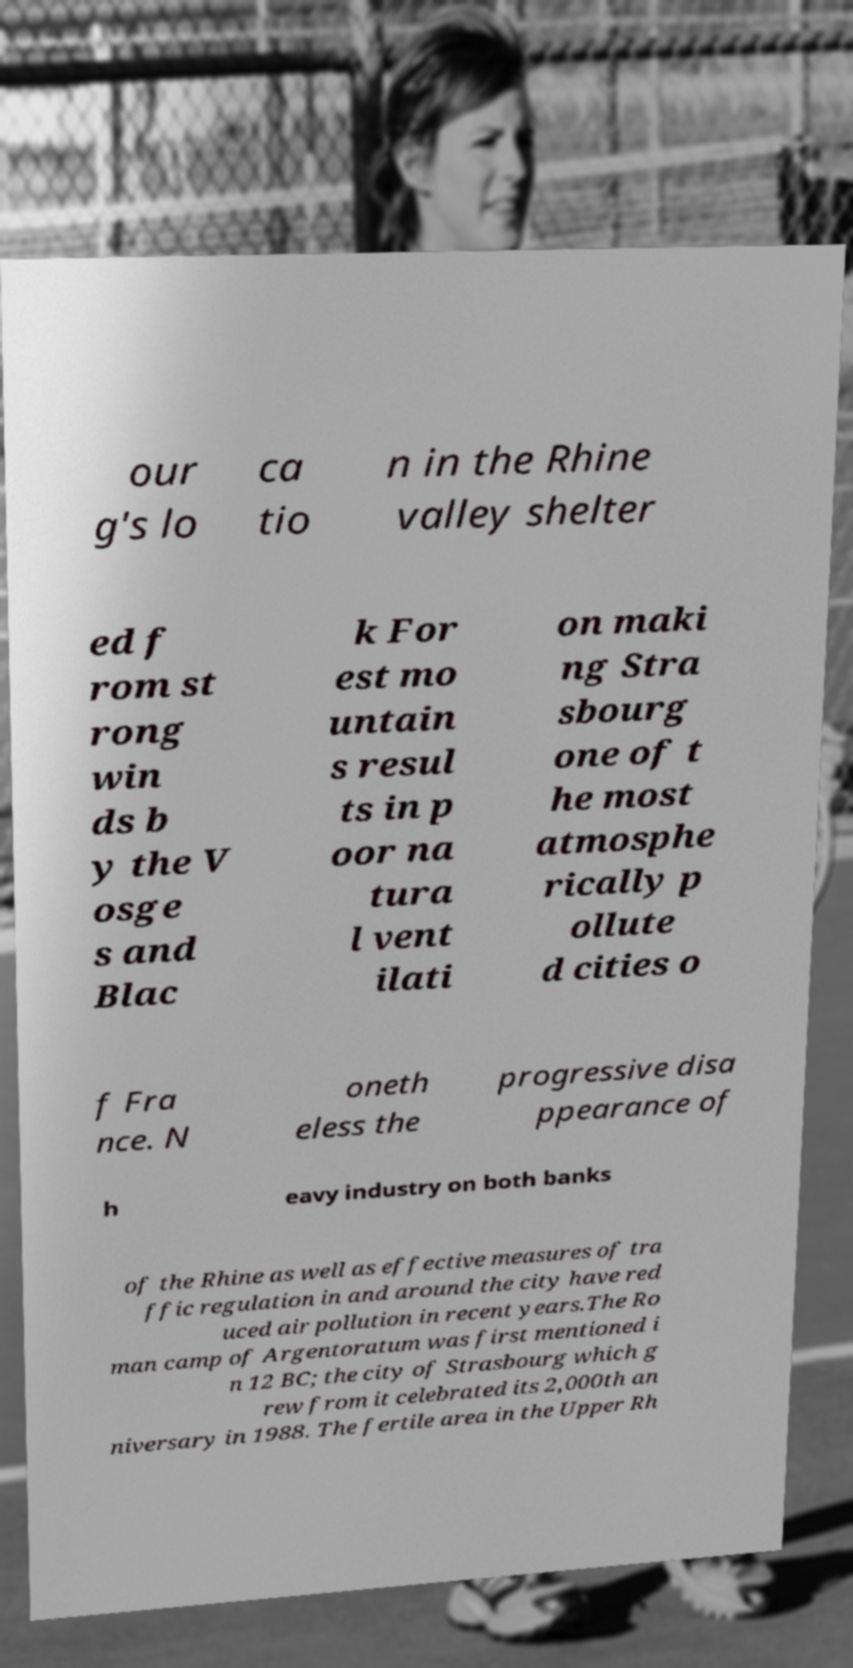I need the written content from this picture converted into text. Can you do that? our g's lo ca tio n in the Rhine valley shelter ed f rom st rong win ds b y the V osge s and Blac k For est mo untain s resul ts in p oor na tura l vent ilati on maki ng Stra sbourg one of t he most atmosphe rically p ollute d cities o f Fra nce. N oneth eless the progressive disa ppearance of h eavy industry on both banks of the Rhine as well as effective measures of tra ffic regulation in and around the city have red uced air pollution in recent years.The Ro man camp of Argentoratum was first mentioned i n 12 BC; the city of Strasbourg which g rew from it celebrated its 2,000th an niversary in 1988. The fertile area in the Upper Rh 